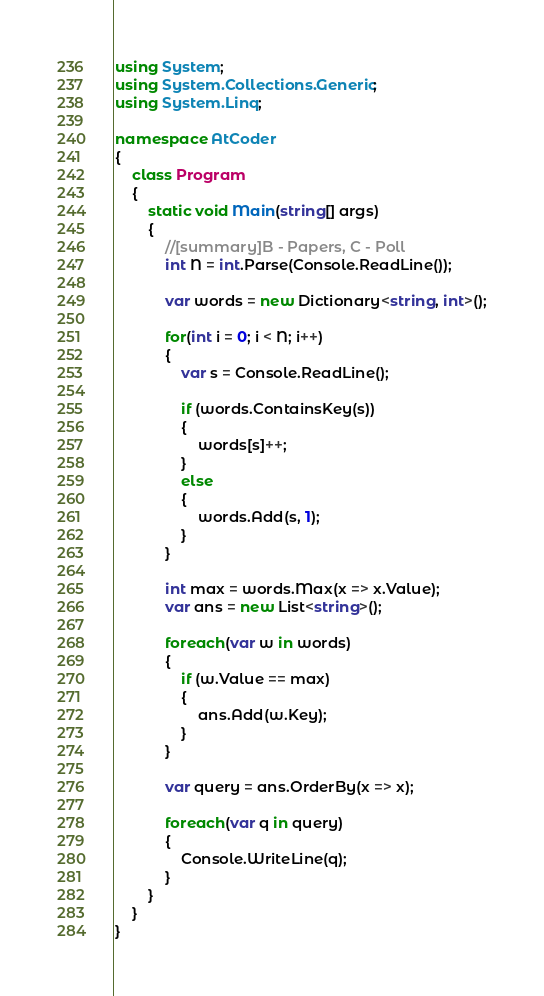<code> <loc_0><loc_0><loc_500><loc_500><_C#_>using System;
using System.Collections.Generic;
using System.Linq;

namespace AtCoder
{
    class Program
    {
        static void Main(string[] args)
        {
            //[summary]B - Papers, C - Poll
            int N = int.Parse(Console.ReadLine());

            var words = new Dictionary<string, int>();

            for(int i = 0; i < N; i++)
            {
                var s = Console.ReadLine();

                if (words.ContainsKey(s))
                {
                    words[s]++;
                }
                else
                {
                    words.Add(s, 1);
                }
            }

            int max = words.Max(x => x.Value);
            var ans = new List<string>();

            foreach(var w in words)
            {
                if (w.Value == max)
                {
                    ans.Add(w.Key);
                }
            }

            var query = ans.OrderBy(x => x);

            foreach(var q in query)
            {
                Console.WriteLine(q);
            }
        }
    }
}</code> 